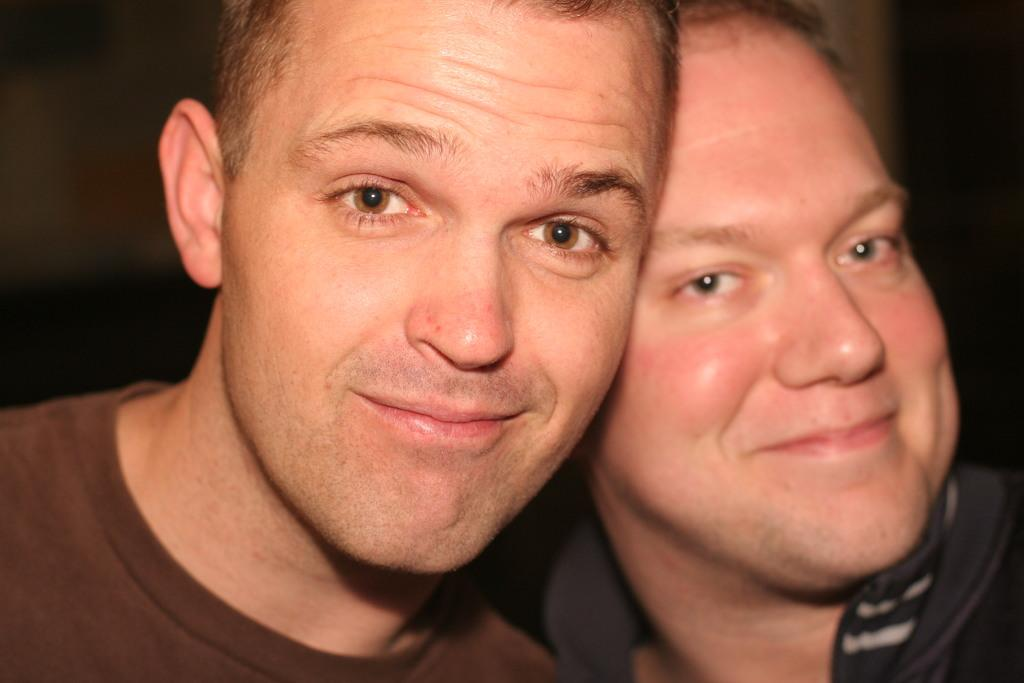How many people are in the image? There are two men in the image. What expressions do the men have? The men are smiling in the image. Can you describe the background of the image? The background of the image is blurry. How many girls are present in the image? There are no girls present in the image; it features two men. Can you tell me what type of kitten is sitting on the men's shoulders in the image? There is no kitten present in the image. 